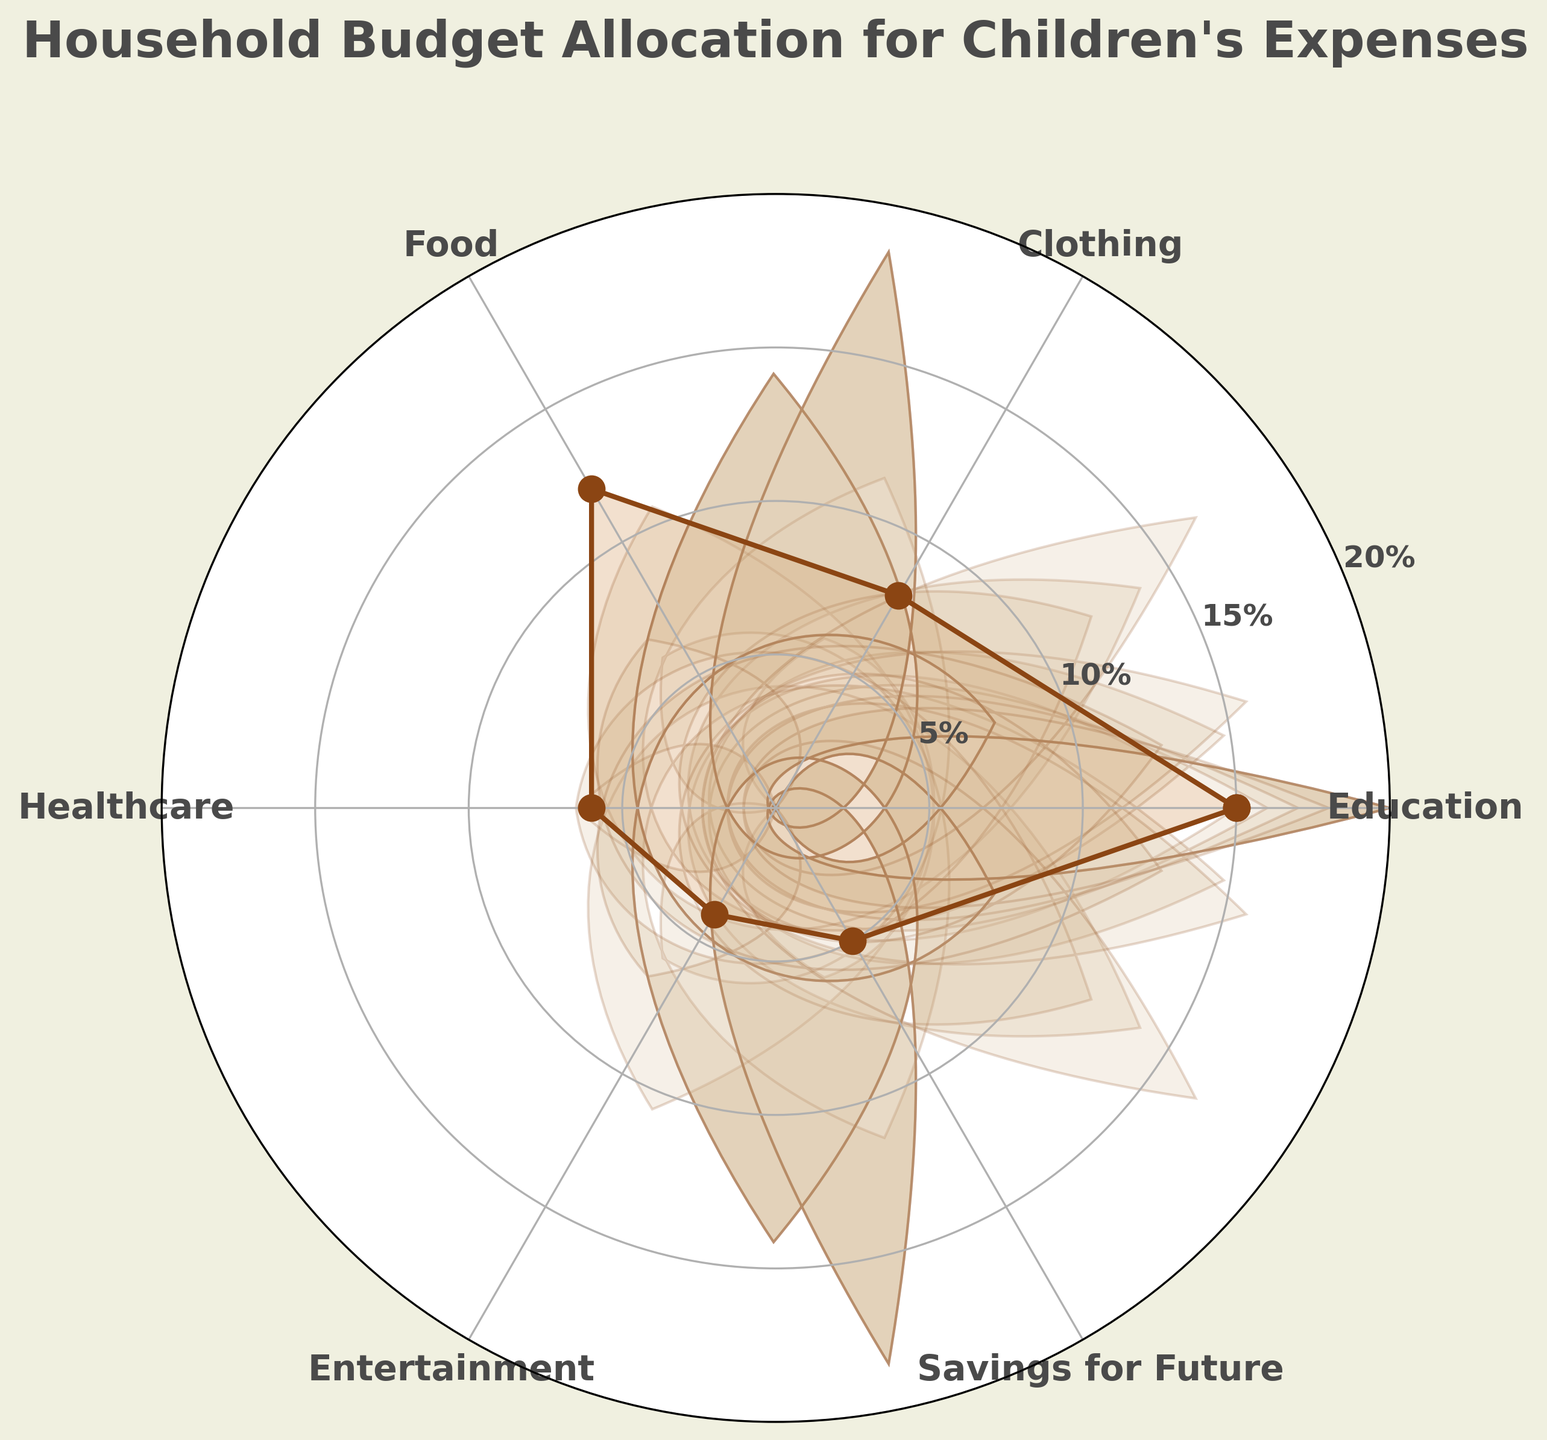What is the percentage allocated to children's clothing expenses? The category "Clothing" shows a percentage value on the radial plot. Look at the position labeled "Clothing" and read the value indicated by the plot.
Answer: 8% What is the total percentage allocated to children's food and entertainment expenses combined? Find the percentage values for "Food" and "Entertainment" on the plot. Add these values together: 12% (Food) + 4% (Entertainment) = 16%.
Answer: 16% Which category has the highest percentage allocation? Identify all percentage values on the plot and compare them. The highest value will be the largest number shown. Education has the highest value at 15%.
Answer: Education How does the percentage allocated to children's healthcare expenses compare to that for entertainment? Look at the values for "Healthcare" and "Entertainment" on the plot. Compare these values: 6% (Healthcare) is greater than 4% (Entertainment).
Answer: Healthcare > Entertainment What percentage of the household budget is allocated to savings for the future relative to the total budget shown? All categories sum to 50%. Calculate the relative percentage for "Savings for Future" as (5% / 50%) * 100, which equals 10%.
Answer: 10% What is the average percentage allocated across all categories on the plot? Sum up all percentages: 15% + 8% + 12% + 6% + 4% + 5% = 50%. There are 6 categories. Divide the total sum by the number of categories: 50 / 6 ≈ 8.33%.
Answer: 8.33% What is the category with the smallest allocation and its value? Find the smallest value from all the percentage points on the plot. The smallest value is 4% for "Entertainment".
Answer: Entertainment, 4% Is the percentage allocated to education greater than the sum of savings for the future and healthcare? Compare 15% (Education) directly to the sum of 5% (Savings) and 6% (Healthcare), which totals 11%. Since 15% > 11%, the answer is yes.
Answer: Yes Which two categories have a combined allocation percentage equal to that of education? Identify pairs of categories and sum their values until one matches the allocation for "Education" (15%). "Food" (12%) + "Entertainment" (4%) = 16%, closest to 15% but consider smaller pair first. "Food" (12%) + "Clothing" (8%) = 20%. Finally, "Food" (12%) + "Healthcare" (6%) or any pairs do not add precisely, approximate.
Answer: None exactly. Possible close sets: "Food" + "Entertainment" How many categories have a percentage allocation higher than 5%? Count the categories on the plot. Those higher than 5% are: Education (15%), Clothing (8%), Food (12%), and Healthcare (6%).
Answer: 4 categories 